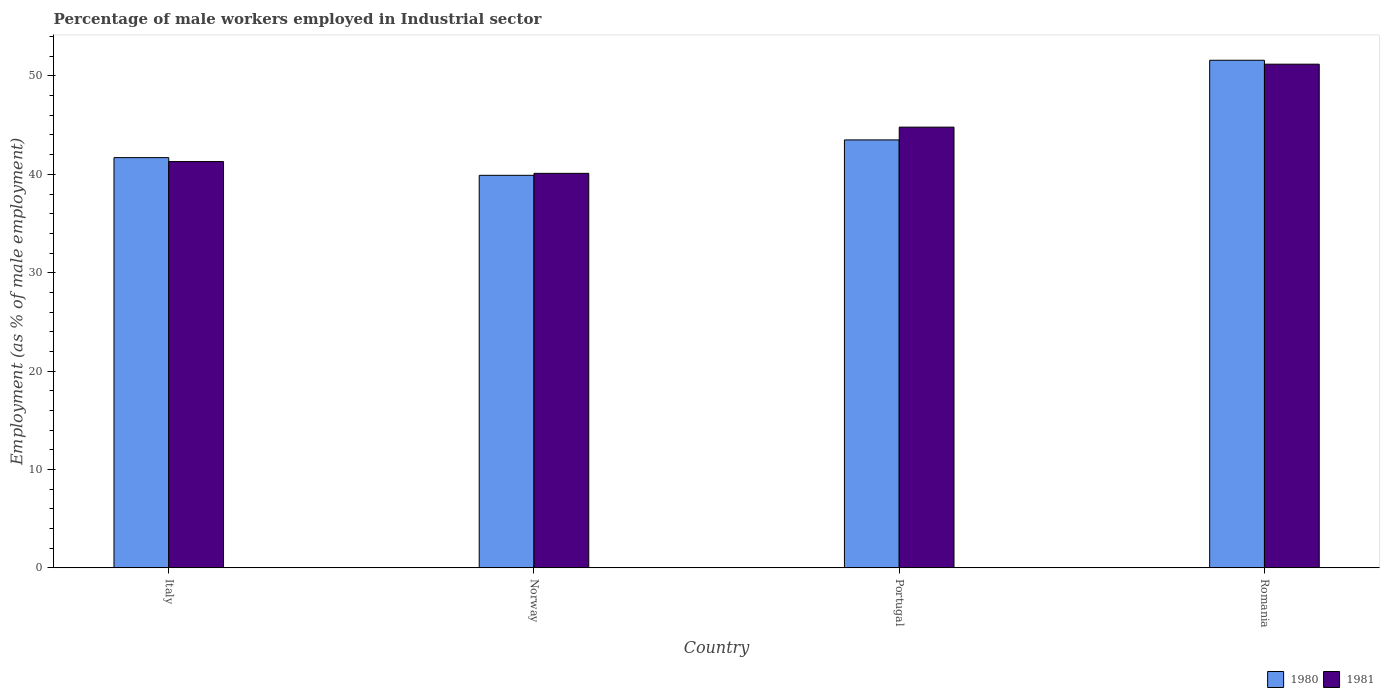How many different coloured bars are there?
Make the answer very short. 2. How many groups of bars are there?
Offer a very short reply. 4. Are the number of bars per tick equal to the number of legend labels?
Keep it short and to the point. Yes. What is the label of the 4th group of bars from the left?
Give a very brief answer. Romania. In how many cases, is the number of bars for a given country not equal to the number of legend labels?
Offer a very short reply. 0. What is the percentage of male workers employed in Industrial sector in 1980 in Norway?
Make the answer very short. 39.9. Across all countries, what is the maximum percentage of male workers employed in Industrial sector in 1981?
Your answer should be very brief. 51.2. Across all countries, what is the minimum percentage of male workers employed in Industrial sector in 1980?
Your answer should be very brief. 39.9. In which country was the percentage of male workers employed in Industrial sector in 1981 maximum?
Your response must be concise. Romania. In which country was the percentage of male workers employed in Industrial sector in 1981 minimum?
Ensure brevity in your answer.  Norway. What is the total percentage of male workers employed in Industrial sector in 1981 in the graph?
Your response must be concise. 177.4. What is the difference between the percentage of male workers employed in Industrial sector in 1981 in Portugal and that in Romania?
Provide a succinct answer. -6.4. What is the difference between the percentage of male workers employed in Industrial sector in 1980 in Norway and the percentage of male workers employed in Industrial sector in 1981 in Italy?
Offer a very short reply. -1.4. What is the average percentage of male workers employed in Industrial sector in 1980 per country?
Ensure brevity in your answer.  44.18. What is the difference between the percentage of male workers employed in Industrial sector of/in 1980 and percentage of male workers employed in Industrial sector of/in 1981 in Portugal?
Offer a terse response. -1.3. In how many countries, is the percentage of male workers employed in Industrial sector in 1981 greater than 6 %?
Keep it short and to the point. 4. What is the ratio of the percentage of male workers employed in Industrial sector in 1980 in Italy to that in Norway?
Give a very brief answer. 1.05. Is the percentage of male workers employed in Industrial sector in 1981 in Norway less than that in Romania?
Your answer should be very brief. Yes. What is the difference between the highest and the second highest percentage of male workers employed in Industrial sector in 1981?
Your answer should be very brief. -9.9. What is the difference between the highest and the lowest percentage of male workers employed in Industrial sector in 1980?
Offer a very short reply. 11.7. What does the 1st bar from the left in Romania represents?
Offer a terse response. 1980. How many countries are there in the graph?
Offer a terse response. 4. Are the values on the major ticks of Y-axis written in scientific E-notation?
Offer a very short reply. No. Does the graph contain any zero values?
Provide a short and direct response. No. Does the graph contain grids?
Offer a very short reply. No. How many legend labels are there?
Your answer should be compact. 2. What is the title of the graph?
Provide a short and direct response. Percentage of male workers employed in Industrial sector. Does "2010" appear as one of the legend labels in the graph?
Your response must be concise. No. What is the label or title of the X-axis?
Provide a short and direct response. Country. What is the label or title of the Y-axis?
Give a very brief answer. Employment (as % of male employment). What is the Employment (as % of male employment) in 1980 in Italy?
Your answer should be very brief. 41.7. What is the Employment (as % of male employment) in 1981 in Italy?
Provide a succinct answer. 41.3. What is the Employment (as % of male employment) in 1980 in Norway?
Your response must be concise. 39.9. What is the Employment (as % of male employment) in 1981 in Norway?
Offer a very short reply. 40.1. What is the Employment (as % of male employment) of 1980 in Portugal?
Offer a terse response. 43.5. What is the Employment (as % of male employment) in 1981 in Portugal?
Offer a very short reply. 44.8. What is the Employment (as % of male employment) in 1980 in Romania?
Offer a terse response. 51.6. What is the Employment (as % of male employment) of 1981 in Romania?
Offer a terse response. 51.2. Across all countries, what is the maximum Employment (as % of male employment) of 1980?
Keep it short and to the point. 51.6. Across all countries, what is the maximum Employment (as % of male employment) of 1981?
Keep it short and to the point. 51.2. Across all countries, what is the minimum Employment (as % of male employment) in 1980?
Offer a very short reply. 39.9. Across all countries, what is the minimum Employment (as % of male employment) in 1981?
Your response must be concise. 40.1. What is the total Employment (as % of male employment) of 1980 in the graph?
Ensure brevity in your answer.  176.7. What is the total Employment (as % of male employment) in 1981 in the graph?
Provide a short and direct response. 177.4. What is the difference between the Employment (as % of male employment) in 1980 in Italy and that in Norway?
Your response must be concise. 1.8. What is the difference between the Employment (as % of male employment) of 1981 in Italy and that in Norway?
Your answer should be very brief. 1.2. What is the difference between the Employment (as % of male employment) of 1981 in Italy and that in Romania?
Your answer should be compact. -9.9. What is the difference between the Employment (as % of male employment) in 1980 in Italy and the Employment (as % of male employment) in 1981 in Norway?
Offer a terse response. 1.6. What is the difference between the Employment (as % of male employment) in 1980 in Italy and the Employment (as % of male employment) in 1981 in Portugal?
Provide a short and direct response. -3.1. What is the difference between the Employment (as % of male employment) of 1980 in Italy and the Employment (as % of male employment) of 1981 in Romania?
Offer a terse response. -9.5. What is the difference between the Employment (as % of male employment) in 1980 in Norway and the Employment (as % of male employment) in 1981 in Portugal?
Offer a very short reply. -4.9. What is the average Employment (as % of male employment) in 1980 per country?
Provide a short and direct response. 44.17. What is the average Employment (as % of male employment) of 1981 per country?
Provide a succinct answer. 44.35. What is the difference between the Employment (as % of male employment) in 1980 and Employment (as % of male employment) in 1981 in Italy?
Ensure brevity in your answer.  0.4. What is the difference between the Employment (as % of male employment) of 1980 and Employment (as % of male employment) of 1981 in Norway?
Provide a short and direct response. -0.2. What is the difference between the Employment (as % of male employment) of 1980 and Employment (as % of male employment) of 1981 in Romania?
Your response must be concise. 0.4. What is the ratio of the Employment (as % of male employment) of 1980 in Italy to that in Norway?
Your response must be concise. 1.05. What is the ratio of the Employment (as % of male employment) of 1981 in Italy to that in Norway?
Keep it short and to the point. 1.03. What is the ratio of the Employment (as % of male employment) in 1980 in Italy to that in Portugal?
Make the answer very short. 0.96. What is the ratio of the Employment (as % of male employment) of 1981 in Italy to that in Portugal?
Your answer should be compact. 0.92. What is the ratio of the Employment (as % of male employment) in 1980 in Italy to that in Romania?
Your response must be concise. 0.81. What is the ratio of the Employment (as % of male employment) in 1981 in Italy to that in Romania?
Your response must be concise. 0.81. What is the ratio of the Employment (as % of male employment) of 1980 in Norway to that in Portugal?
Give a very brief answer. 0.92. What is the ratio of the Employment (as % of male employment) in 1981 in Norway to that in Portugal?
Keep it short and to the point. 0.9. What is the ratio of the Employment (as % of male employment) of 1980 in Norway to that in Romania?
Your answer should be very brief. 0.77. What is the ratio of the Employment (as % of male employment) of 1981 in Norway to that in Romania?
Provide a short and direct response. 0.78. What is the ratio of the Employment (as % of male employment) of 1980 in Portugal to that in Romania?
Your response must be concise. 0.84. What is the ratio of the Employment (as % of male employment) in 1981 in Portugal to that in Romania?
Give a very brief answer. 0.88. What is the difference between the highest and the second highest Employment (as % of male employment) in 1981?
Offer a very short reply. 6.4. What is the difference between the highest and the lowest Employment (as % of male employment) in 1980?
Ensure brevity in your answer.  11.7. 